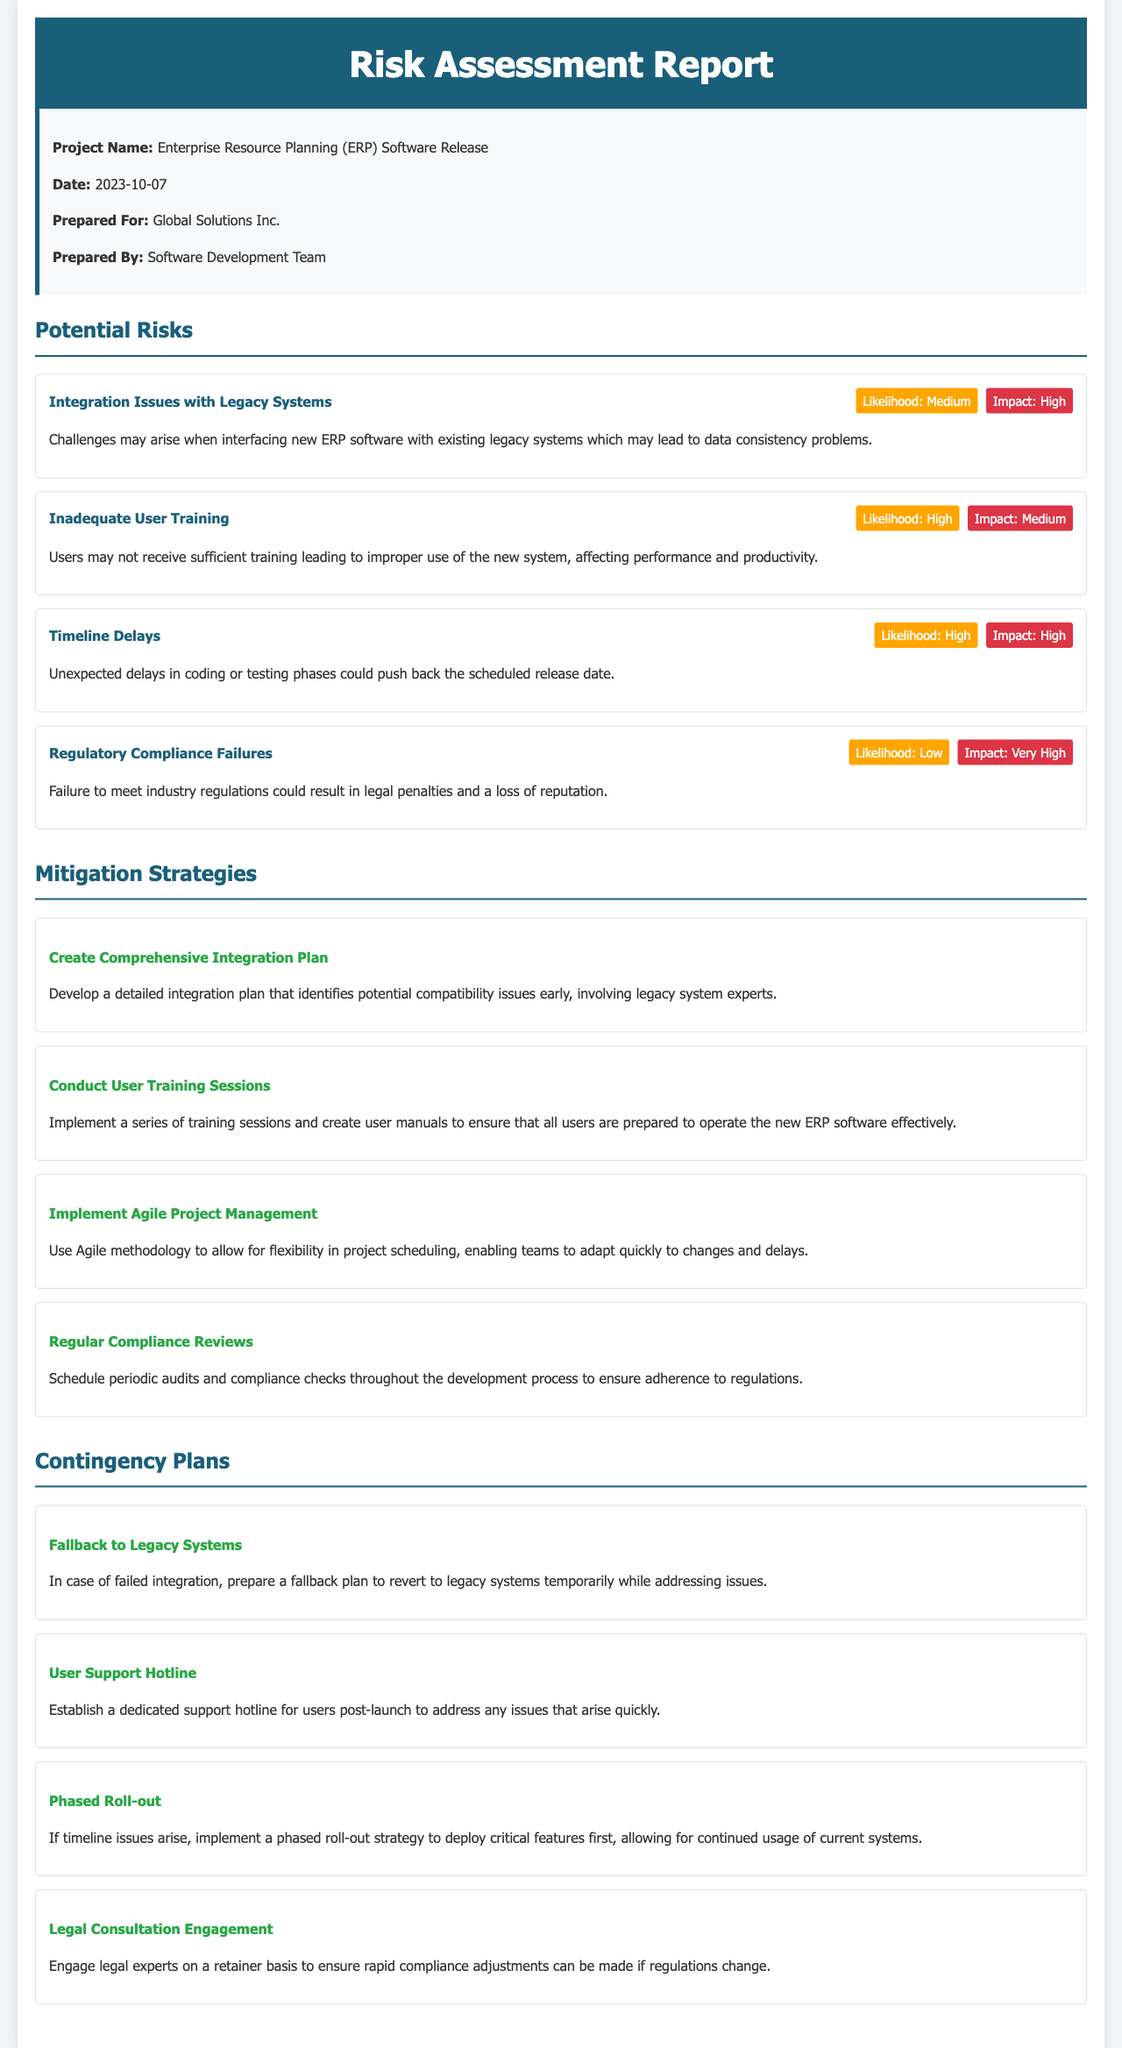What is the project name? The project name is stated in the metadata section, which identifies the focus of the report.
Answer: Enterprise Resource Planning (ERP) Software Release What is the date of the report? The date is provided in the meta-info section of the document.
Answer: 2023-10-07 Who prepared the report? The report's author is indicated in the meta-info section that notes the creator of the document.
Answer: Software Development Team What is the likelihood of integration issues with legacy systems? The likelihood metric associated with this risk is found within the risk item description.
Answer: Medium What is the impact of inadequate user training? The impact level is noted within the corresponding risk item for user training in the document.
Answer: Medium What strategy is recommended for user training? The mitigation strategies section details specific recommendations for user training improvement.
Answer: Conduct User Training Sessions What contingency plan is suggested in case of failed integration? The contingency plans section shares alternative actions to take in the event of specific risk occurrences.
Answer: Fallback to Legacy Systems How many potential risks are listed? The number of risk items can be counted directly in the section for potential risks.
Answer: Four What is a key impact of regulatory compliance failures? The impact associated with this risk is highlighted in the metrics presented.
Answer: Very High What is the title of the last mitigation strategy mentioned? The final strategy item provides a title at the beginning of the description listed under mitigation strategies.
Answer: Regular Compliance Reviews 